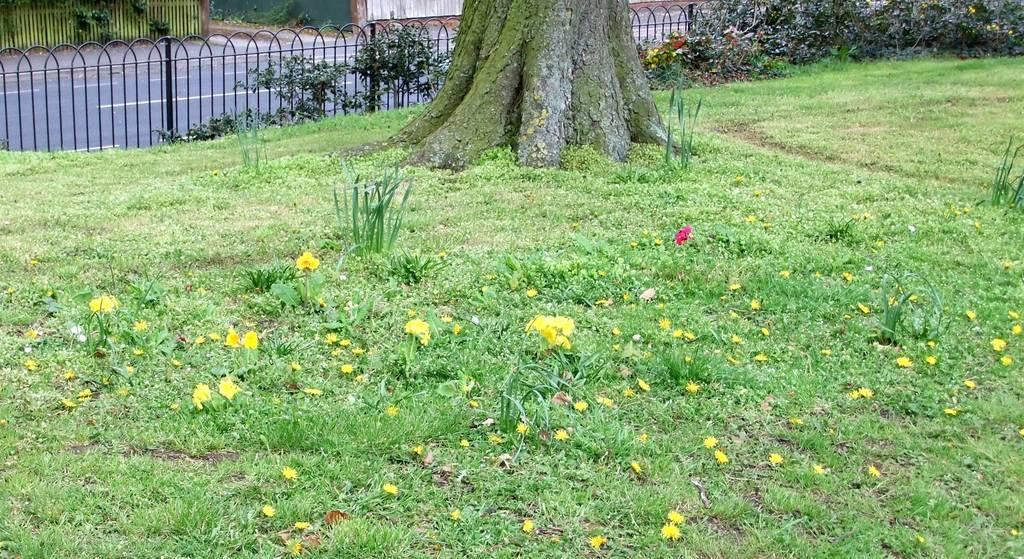What type of vegetation can be seen on the grass in the image? There are flowers on the surface of the grass in the image. What other types of vegetation are present in the image? There are trees and plants in the image. What can be seen near the vegetation in the image? There is a railing visible in the image. What is located behind the railing in the image? There is a road behind the railing in the image. Can you tell me how many birds are in the nest in the image? There is no nest present in the image; it features flowers on the grass, trees, plants, a railing, and a road. How does the process of helping the plants grow work in the image? The image does not show any specific process of helping the plants grow; it simply depicts the plants and flowers in their natural environment. 